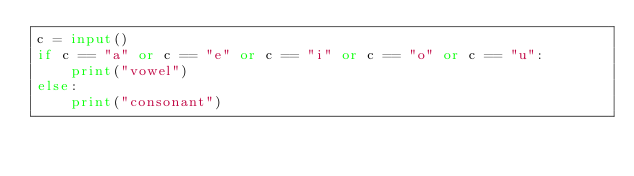<code> <loc_0><loc_0><loc_500><loc_500><_Python_>c = input()
if c == "a" or c == "e" or c == "i" or c == "o" or c == "u":
    print("vowel")
else:
    print("consonant")</code> 